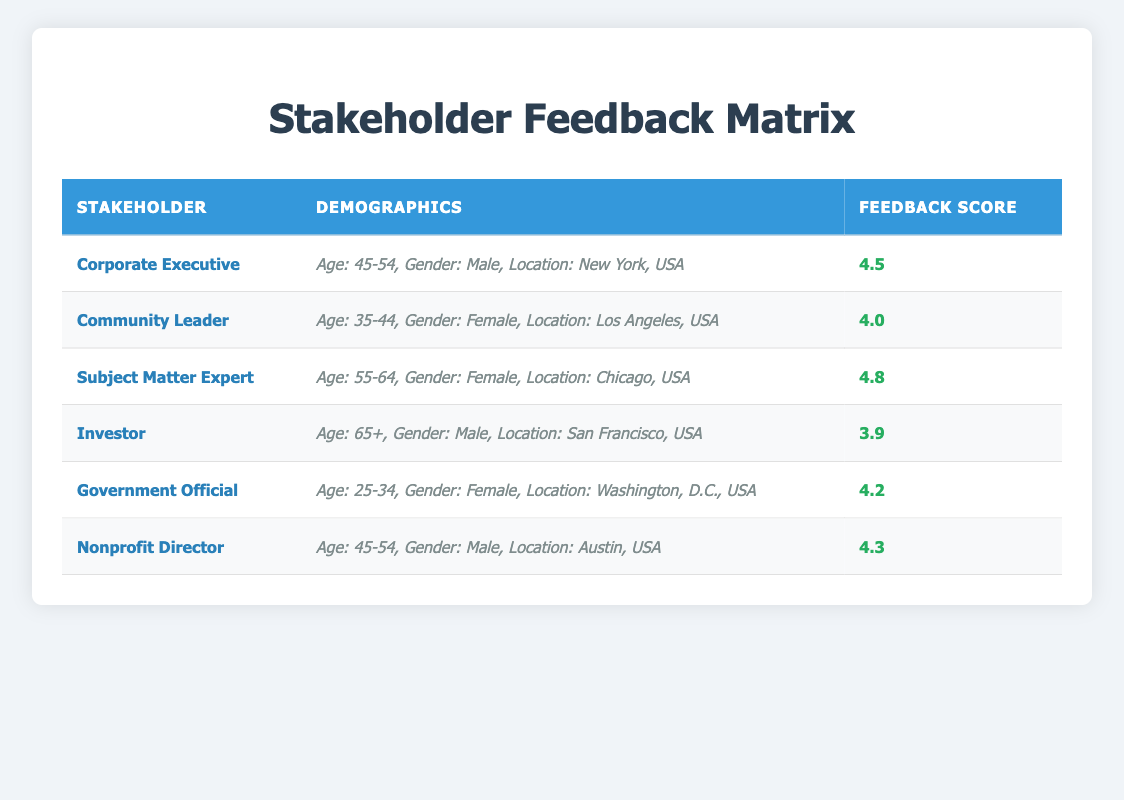What is the feedback score of the Subject Matter Expert? The feedback score for the Subject Matter Expert is listed in the table under the respective row. The score is 4.8.
Answer: 4.8 Which stakeholder has the highest feedback score? To find the highest score, I compare all the feedback scores in the table. The Subject Matter Expert has the highest score of 4.8.
Answer: Subject Matter Expert Is the Corporate Executive's feedback score greater than 4.0? The Corporate Executive's score of 4.5 can be directly compared to 4.0. Since 4.5 is greater than 4.0, the answer is yes.
Answer: Yes What is the average feedback score of male stakeholders? The scores of male stakeholders are as follows: Corporate Executive (4.5), Investor (3.9), and Nonprofit Director (4.3). Adding these scores gives 4.5 + 3.9 + 4.3 = 12.7, and dividing by 3 yields an average of 4.23.
Answer: 4.23 Is there any stakeholder from Washington, D.C., USA? By reviewing the table, the Government Official is the only stakeholder listed with Washington, D.C. as their location. Therefore, the answer is yes.
Answer: Yes What is the difference between the feedback scores of the Community Leader and the Investor? The Community Leader has a score of 4.0 while the Investor has a score of 3.9. The difference is calculated as 4.0 - 3.9 = 0.1.
Answer: 0.1 How many stakeholders have a feedback score above 4.0? In reviewing the table, the stakeholders with feedback scores above 4.0 are the Corporate Executive (4.5), Subject Matter Expert (4.8), Government Official (4.2), and Nonprofit Director (4.3). This totals to 4 stakeholders.
Answer: 4 Are there any female stakeholders with a feedback score below 4.0? The only female stakeholder in the table with a score below 4.0 is the Investor, who has a score of 3.9. Therefore, the answer is yes.
Answer: Yes What is the feedback score for the youngest age group, which is 25-34? The Government Official falls into the 25-34 age range and has a feedback score of 4.2. Therefore, the score for this age group is 4.2.
Answer: 4.2 